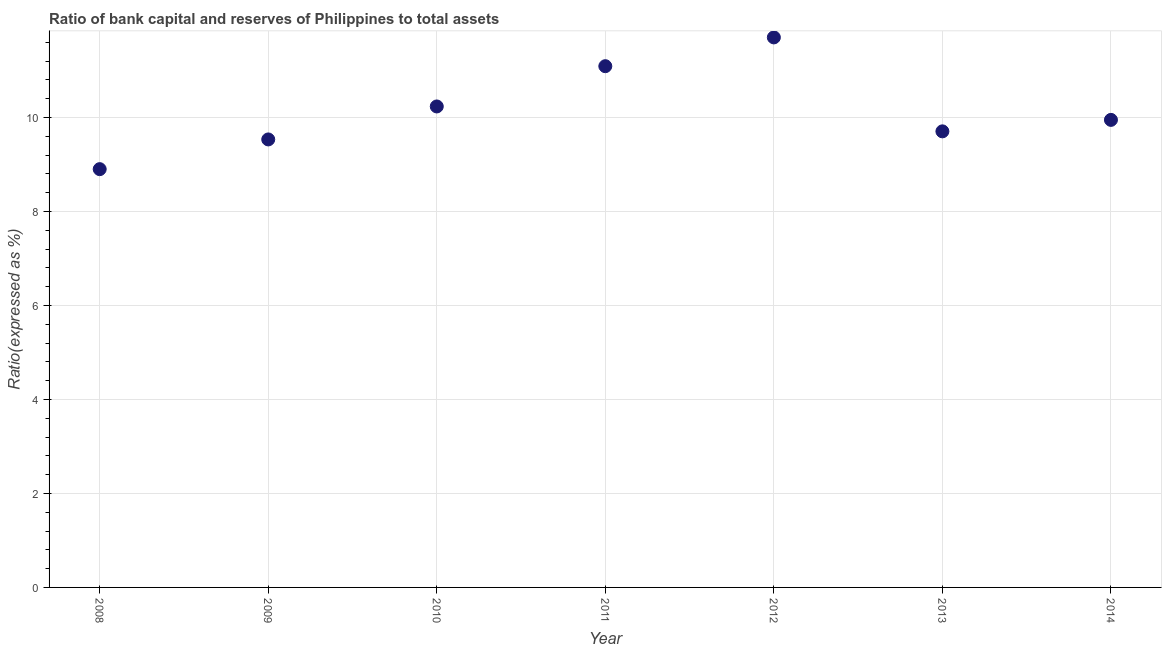What is the bank capital to assets ratio in 2009?
Provide a succinct answer. 9.53. Across all years, what is the maximum bank capital to assets ratio?
Make the answer very short. 11.7. In which year was the bank capital to assets ratio maximum?
Your response must be concise. 2012. In which year was the bank capital to assets ratio minimum?
Make the answer very short. 2008. What is the sum of the bank capital to assets ratio?
Keep it short and to the point. 71.11. What is the difference between the bank capital to assets ratio in 2008 and 2013?
Provide a short and direct response. -0.8. What is the average bank capital to assets ratio per year?
Your response must be concise. 10.16. What is the median bank capital to assets ratio?
Keep it short and to the point. 9.95. Do a majority of the years between 2010 and 2011 (inclusive) have bank capital to assets ratio greater than 10 %?
Your response must be concise. Yes. What is the ratio of the bank capital to assets ratio in 2008 to that in 2012?
Offer a terse response. 0.76. Is the bank capital to assets ratio in 2008 less than that in 2011?
Keep it short and to the point. Yes. What is the difference between the highest and the second highest bank capital to assets ratio?
Keep it short and to the point. 0.61. Is the sum of the bank capital to assets ratio in 2010 and 2011 greater than the maximum bank capital to assets ratio across all years?
Keep it short and to the point. Yes. What is the difference between the highest and the lowest bank capital to assets ratio?
Provide a short and direct response. 2.8. In how many years, is the bank capital to assets ratio greater than the average bank capital to assets ratio taken over all years?
Offer a terse response. 3. How many years are there in the graph?
Provide a succinct answer. 7. What is the difference between two consecutive major ticks on the Y-axis?
Offer a very short reply. 2. Are the values on the major ticks of Y-axis written in scientific E-notation?
Give a very brief answer. No. What is the title of the graph?
Make the answer very short. Ratio of bank capital and reserves of Philippines to total assets. What is the label or title of the Y-axis?
Provide a short and direct response. Ratio(expressed as %). What is the Ratio(expressed as %) in 2008?
Your answer should be very brief. 8.9. What is the Ratio(expressed as %) in 2009?
Give a very brief answer. 9.53. What is the Ratio(expressed as %) in 2010?
Ensure brevity in your answer.  10.23. What is the Ratio(expressed as %) in 2011?
Your answer should be compact. 11.09. What is the Ratio(expressed as %) in 2012?
Your answer should be compact. 11.7. What is the Ratio(expressed as %) in 2013?
Keep it short and to the point. 9.7. What is the Ratio(expressed as %) in 2014?
Keep it short and to the point. 9.95. What is the difference between the Ratio(expressed as %) in 2008 and 2009?
Provide a succinct answer. -0.63. What is the difference between the Ratio(expressed as %) in 2008 and 2010?
Provide a short and direct response. -1.33. What is the difference between the Ratio(expressed as %) in 2008 and 2011?
Offer a very short reply. -2.19. What is the difference between the Ratio(expressed as %) in 2008 and 2012?
Your response must be concise. -2.8. What is the difference between the Ratio(expressed as %) in 2008 and 2013?
Provide a succinct answer. -0.8. What is the difference between the Ratio(expressed as %) in 2008 and 2014?
Offer a terse response. -1.05. What is the difference between the Ratio(expressed as %) in 2009 and 2010?
Provide a succinct answer. -0.7. What is the difference between the Ratio(expressed as %) in 2009 and 2011?
Make the answer very short. -1.56. What is the difference between the Ratio(expressed as %) in 2009 and 2012?
Ensure brevity in your answer.  -2.17. What is the difference between the Ratio(expressed as %) in 2009 and 2013?
Ensure brevity in your answer.  -0.17. What is the difference between the Ratio(expressed as %) in 2009 and 2014?
Your answer should be very brief. -0.42. What is the difference between the Ratio(expressed as %) in 2010 and 2011?
Ensure brevity in your answer.  -0.86. What is the difference between the Ratio(expressed as %) in 2010 and 2012?
Make the answer very short. -1.47. What is the difference between the Ratio(expressed as %) in 2010 and 2013?
Provide a succinct answer. 0.53. What is the difference between the Ratio(expressed as %) in 2010 and 2014?
Offer a very short reply. 0.29. What is the difference between the Ratio(expressed as %) in 2011 and 2012?
Keep it short and to the point. -0.61. What is the difference between the Ratio(expressed as %) in 2011 and 2013?
Your answer should be compact. 1.39. What is the difference between the Ratio(expressed as %) in 2011 and 2014?
Your answer should be compact. 1.14. What is the difference between the Ratio(expressed as %) in 2012 and 2013?
Your answer should be compact. 2. What is the difference between the Ratio(expressed as %) in 2012 and 2014?
Make the answer very short. 1.75. What is the difference between the Ratio(expressed as %) in 2013 and 2014?
Your response must be concise. -0.24. What is the ratio of the Ratio(expressed as %) in 2008 to that in 2009?
Make the answer very short. 0.93. What is the ratio of the Ratio(expressed as %) in 2008 to that in 2010?
Provide a short and direct response. 0.87. What is the ratio of the Ratio(expressed as %) in 2008 to that in 2011?
Ensure brevity in your answer.  0.8. What is the ratio of the Ratio(expressed as %) in 2008 to that in 2012?
Offer a very short reply. 0.76. What is the ratio of the Ratio(expressed as %) in 2008 to that in 2013?
Make the answer very short. 0.92. What is the ratio of the Ratio(expressed as %) in 2008 to that in 2014?
Keep it short and to the point. 0.9. What is the ratio of the Ratio(expressed as %) in 2009 to that in 2011?
Provide a short and direct response. 0.86. What is the ratio of the Ratio(expressed as %) in 2009 to that in 2012?
Offer a terse response. 0.81. What is the ratio of the Ratio(expressed as %) in 2009 to that in 2013?
Offer a terse response. 0.98. What is the ratio of the Ratio(expressed as %) in 2009 to that in 2014?
Keep it short and to the point. 0.96. What is the ratio of the Ratio(expressed as %) in 2010 to that in 2011?
Provide a short and direct response. 0.92. What is the ratio of the Ratio(expressed as %) in 2010 to that in 2012?
Offer a terse response. 0.87. What is the ratio of the Ratio(expressed as %) in 2010 to that in 2013?
Provide a short and direct response. 1.05. What is the ratio of the Ratio(expressed as %) in 2010 to that in 2014?
Provide a short and direct response. 1.03. What is the ratio of the Ratio(expressed as %) in 2011 to that in 2012?
Offer a very short reply. 0.95. What is the ratio of the Ratio(expressed as %) in 2011 to that in 2013?
Offer a very short reply. 1.14. What is the ratio of the Ratio(expressed as %) in 2011 to that in 2014?
Your response must be concise. 1.11. What is the ratio of the Ratio(expressed as %) in 2012 to that in 2013?
Offer a terse response. 1.21. What is the ratio of the Ratio(expressed as %) in 2012 to that in 2014?
Provide a succinct answer. 1.18. 